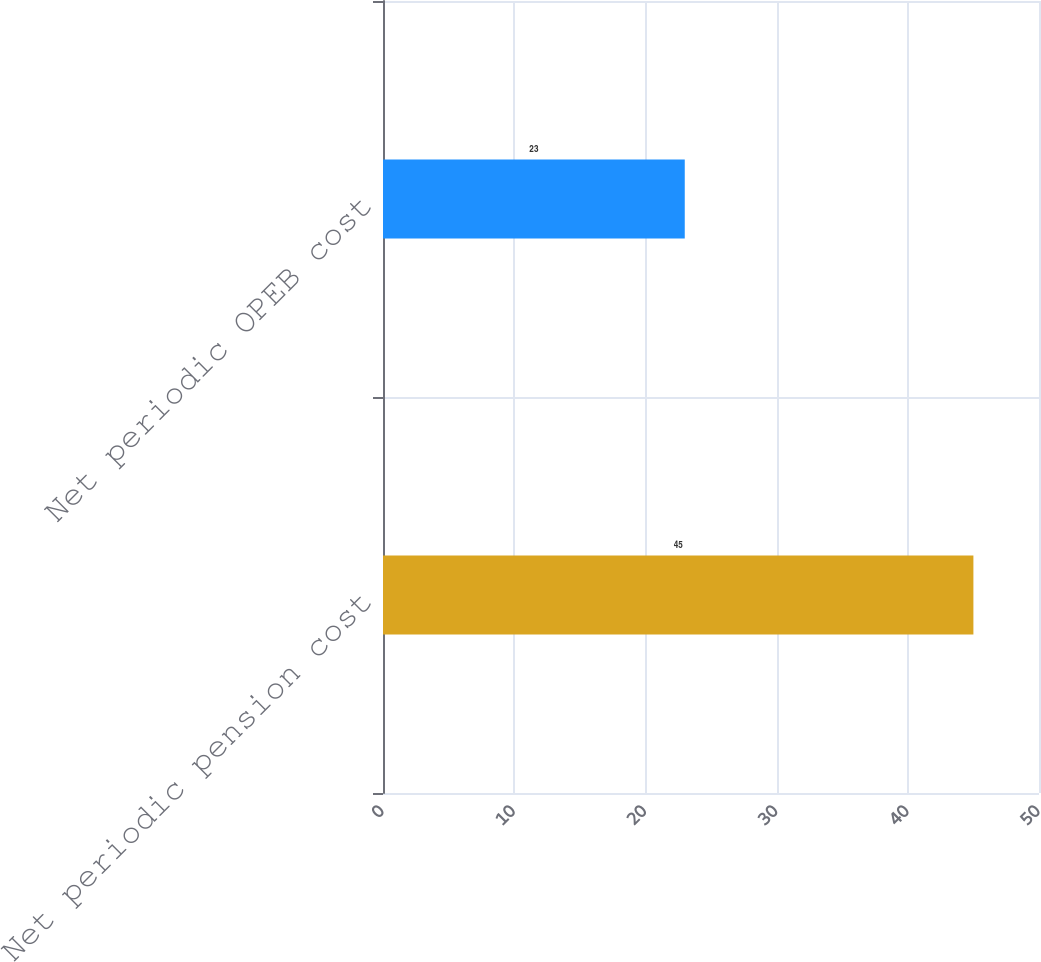Convert chart. <chart><loc_0><loc_0><loc_500><loc_500><bar_chart><fcel>Net periodic pension cost<fcel>Net periodic OPEB cost<nl><fcel>45<fcel>23<nl></chart> 